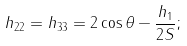<formula> <loc_0><loc_0><loc_500><loc_500>h _ { 2 2 } = h _ { 3 3 } = 2 \cos \theta - \frac { h _ { 1 } } { 2 S } ;</formula> 